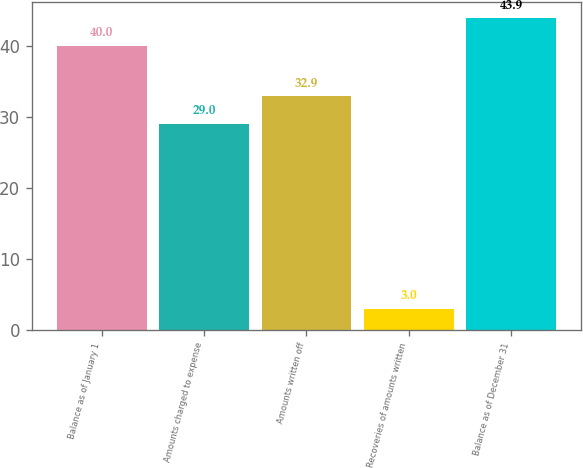<chart> <loc_0><loc_0><loc_500><loc_500><bar_chart><fcel>Balance as of January 1<fcel>Amounts charged to expense<fcel>Amounts written off<fcel>Recoveries of amounts written<fcel>Balance as of December 31<nl><fcel>40<fcel>29<fcel>32.9<fcel>3<fcel>43.9<nl></chart> 